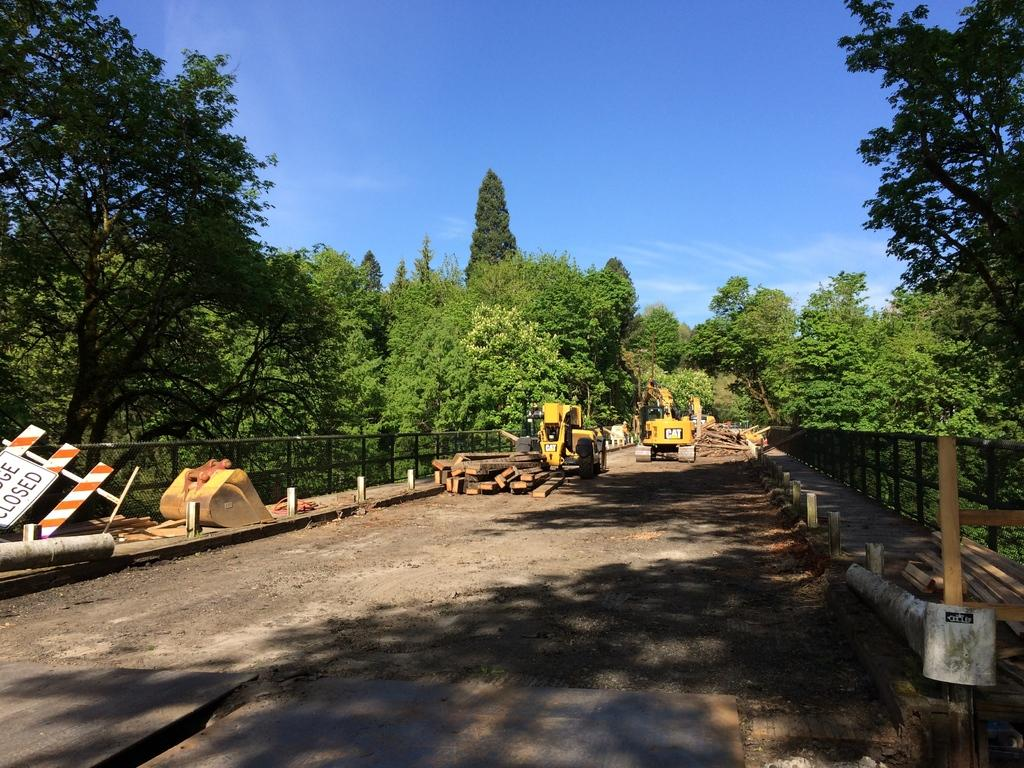What is the main feature of the image? There is a road in the image. Are there any vehicles on the road? Yes, there are two vehicles on the road. What can be seen in the background of the image? There are woods, trees, and clouds in the blue sky visible in the background of the image. What type of barrier is present on both sides of the road? There is a fence on both sides of the road. Can you see a giraffe in the cellar of the image? There is no cellar or giraffe present in the image. What type of winter clothing is being worn by the trees in the background? The trees in the background do not wear winter clothing, as they are not living beings. 